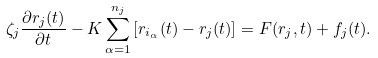<formula> <loc_0><loc_0><loc_500><loc_500>\zeta _ { j } \frac { \partial { r } _ { j } ( t ) } { \partial t } - K \sum _ { \alpha = 1 } ^ { n _ { j } } \left [ { r } _ { i _ { \alpha } } ( t ) - { r } _ { j } ( t ) \right ] = { F } ( { r } _ { j } , t ) + { f } _ { j } ( t ) .</formula> 